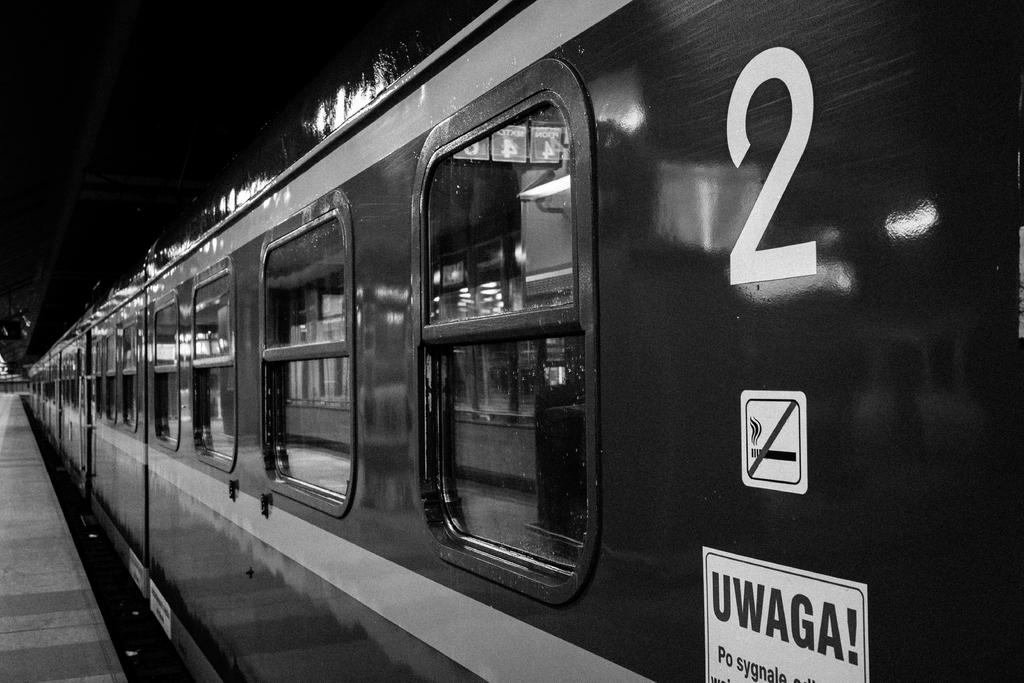<image>
Offer a succinct explanation of the picture presented. A train is at the station and says Uwaga on the side. 